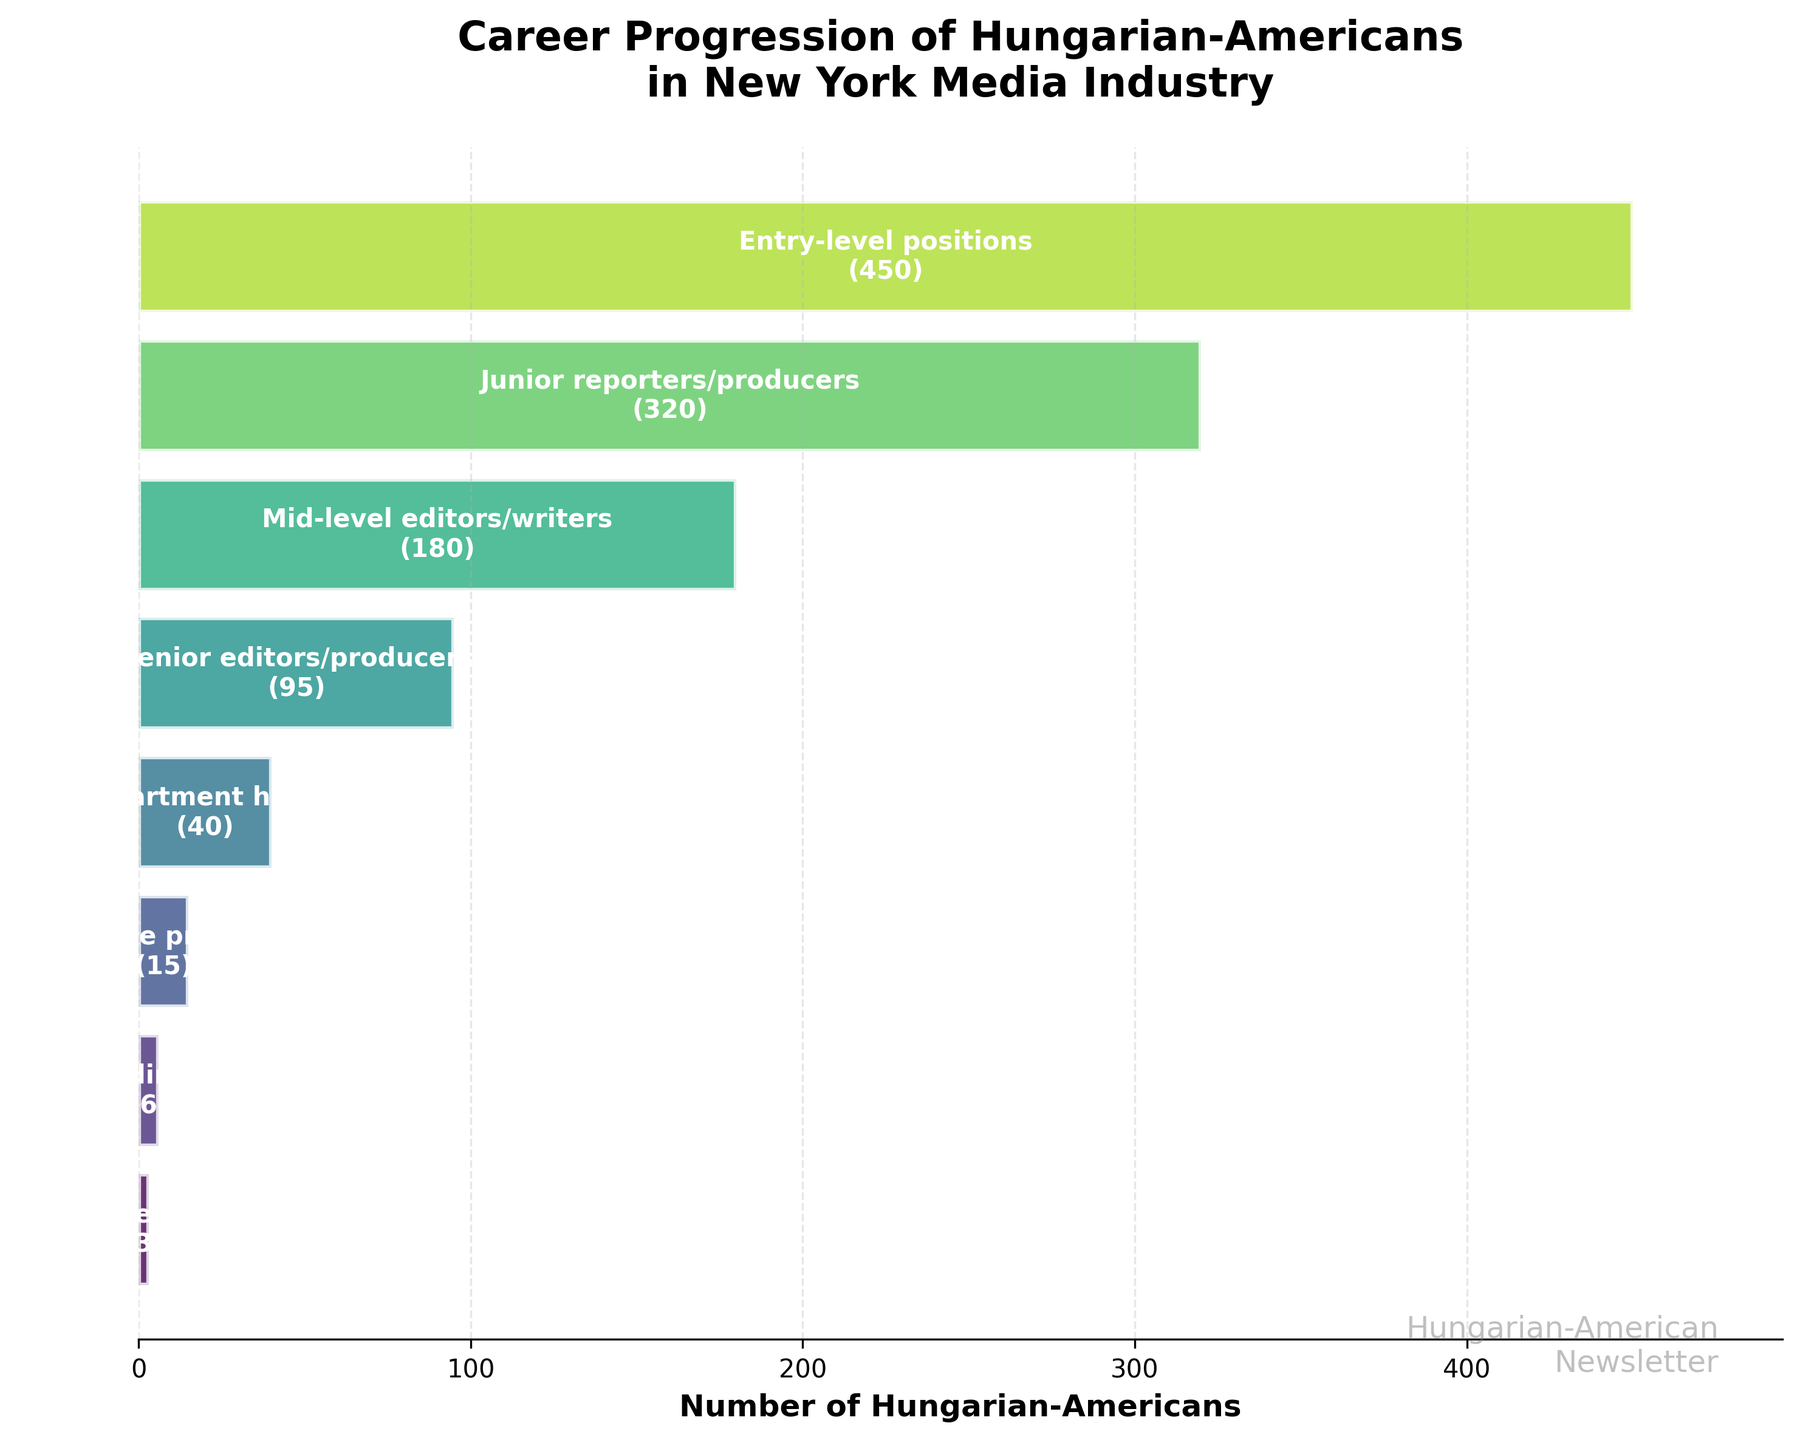What's the total number of Hungarian-Americans in the New York media industry according to the chart? Summing the total numbers of Hungarian-Americans from each stage: 450 + 320 + 180 + 95 + 40 + 15 + 6 + 3 = 1109
Answer: 1109 Which career stage has the highest number of Hungarian-Americans? The entry-level positions stage has the highest number, noted as 450 in the figure.
Answer: Entry-level positions At which career stage is the number of Hungarian-Americans the smallest? The Chief editors stage has the smallest number, noted as 3 in the figure.
Answer: Chief editors How many more Hungarian-Americans are in junior reporter/producer positions than in senior editor/producer positions? The number in junior reporter/producer positions is 320, and in senior editor/producer positions is 95. The difference is 320 - 95 = 225.
Answer: 225 What fraction of the Hungarian-Americans in the New York media industry holds executive producer or higher roles? Adding the numbers in executive producer and higher roles: 15 (Executive producers) + 6 (News directors) + 3 (Chief editors) = 24. The fraction is 24/1109 (total).
Answer: 24/1109 What is the difference in the number of Hungarian-Americans between the mid-level editors/writers and the department head positions? There are 180 in mid-level editors/writers and 40 in department heads. The difference is 180 - 40 = 140.
Answer: 140 By what percentage does the number of Hungarian-Americans decrease from department heads to executive producers? The number decreases from 40 to 15. The percentage decrease is ((40 - 15) / 40) * 100 = 62.5%.
Answer: 62.5% What is the average number of Hungarian-Americans per stage, based on the provided data? Summing the total numbers: 450 + 320 + 180 + 95 + 40 + 15 + 6 + 3 = 1109. There are 8 stages. The average is 1109 / 8.
Answer: 138.625 Which stage shows the steepest decline in the career progression funnel? The decline from junior reporters/producers (320) to mid-level editors/writers (180) is the steepest with a drop of 140.
Answer: From junior reporters/producers to mid-level editors/writers How many Hungarian-Americans are at mid-level or higher positions (from mid-level editors/writers upwards)? Summing the numbers from mid-level onwards: 180 + 95 + 40 + 15 + 6 + 3 = 339.
Answer: 339 